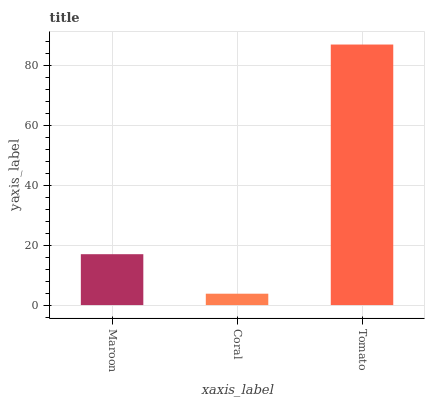Is Coral the minimum?
Answer yes or no. Yes. Is Tomato the maximum?
Answer yes or no. Yes. Is Tomato the minimum?
Answer yes or no. No. Is Coral the maximum?
Answer yes or no. No. Is Tomato greater than Coral?
Answer yes or no. Yes. Is Coral less than Tomato?
Answer yes or no. Yes. Is Coral greater than Tomato?
Answer yes or no. No. Is Tomato less than Coral?
Answer yes or no. No. Is Maroon the high median?
Answer yes or no. Yes. Is Maroon the low median?
Answer yes or no. Yes. Is Coral the high median?
Answer yes or no. No. Is Tomato the low median?
Answer yes or no. No. 